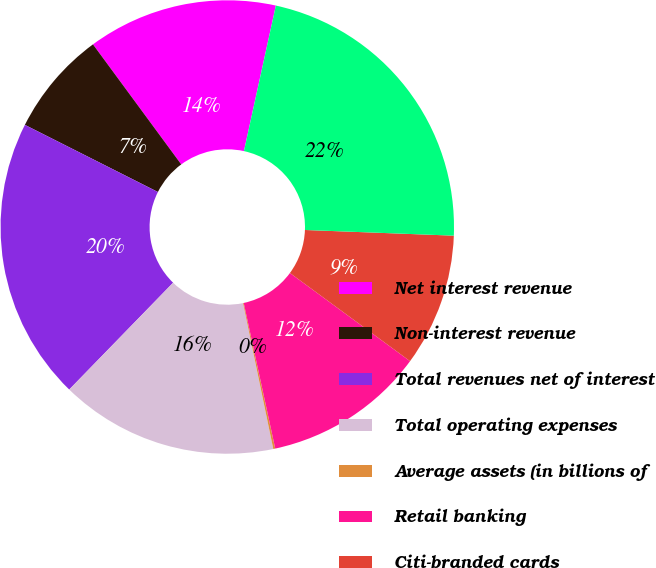Convert chart to OTSL. <chart><loc_0><loc_0><loc_500><loc_500><pie_chart><fcel>Net interest revenue<fcel>Non-interest revenue<fcel>Total revenues net of interest<fcel>Total operating expenses<fcel>Average assets (in billions of<fcel>Retail banking<fcel>Citi-branded cards<fcel>Total<nl><fcel>13.53%<fcel>7.47%<fcel>20.16%<fcel>15.53%<fcel>0.14%<fcel>11.53%<fcel>9.47%<fcel>22.17%<nl></chart> 